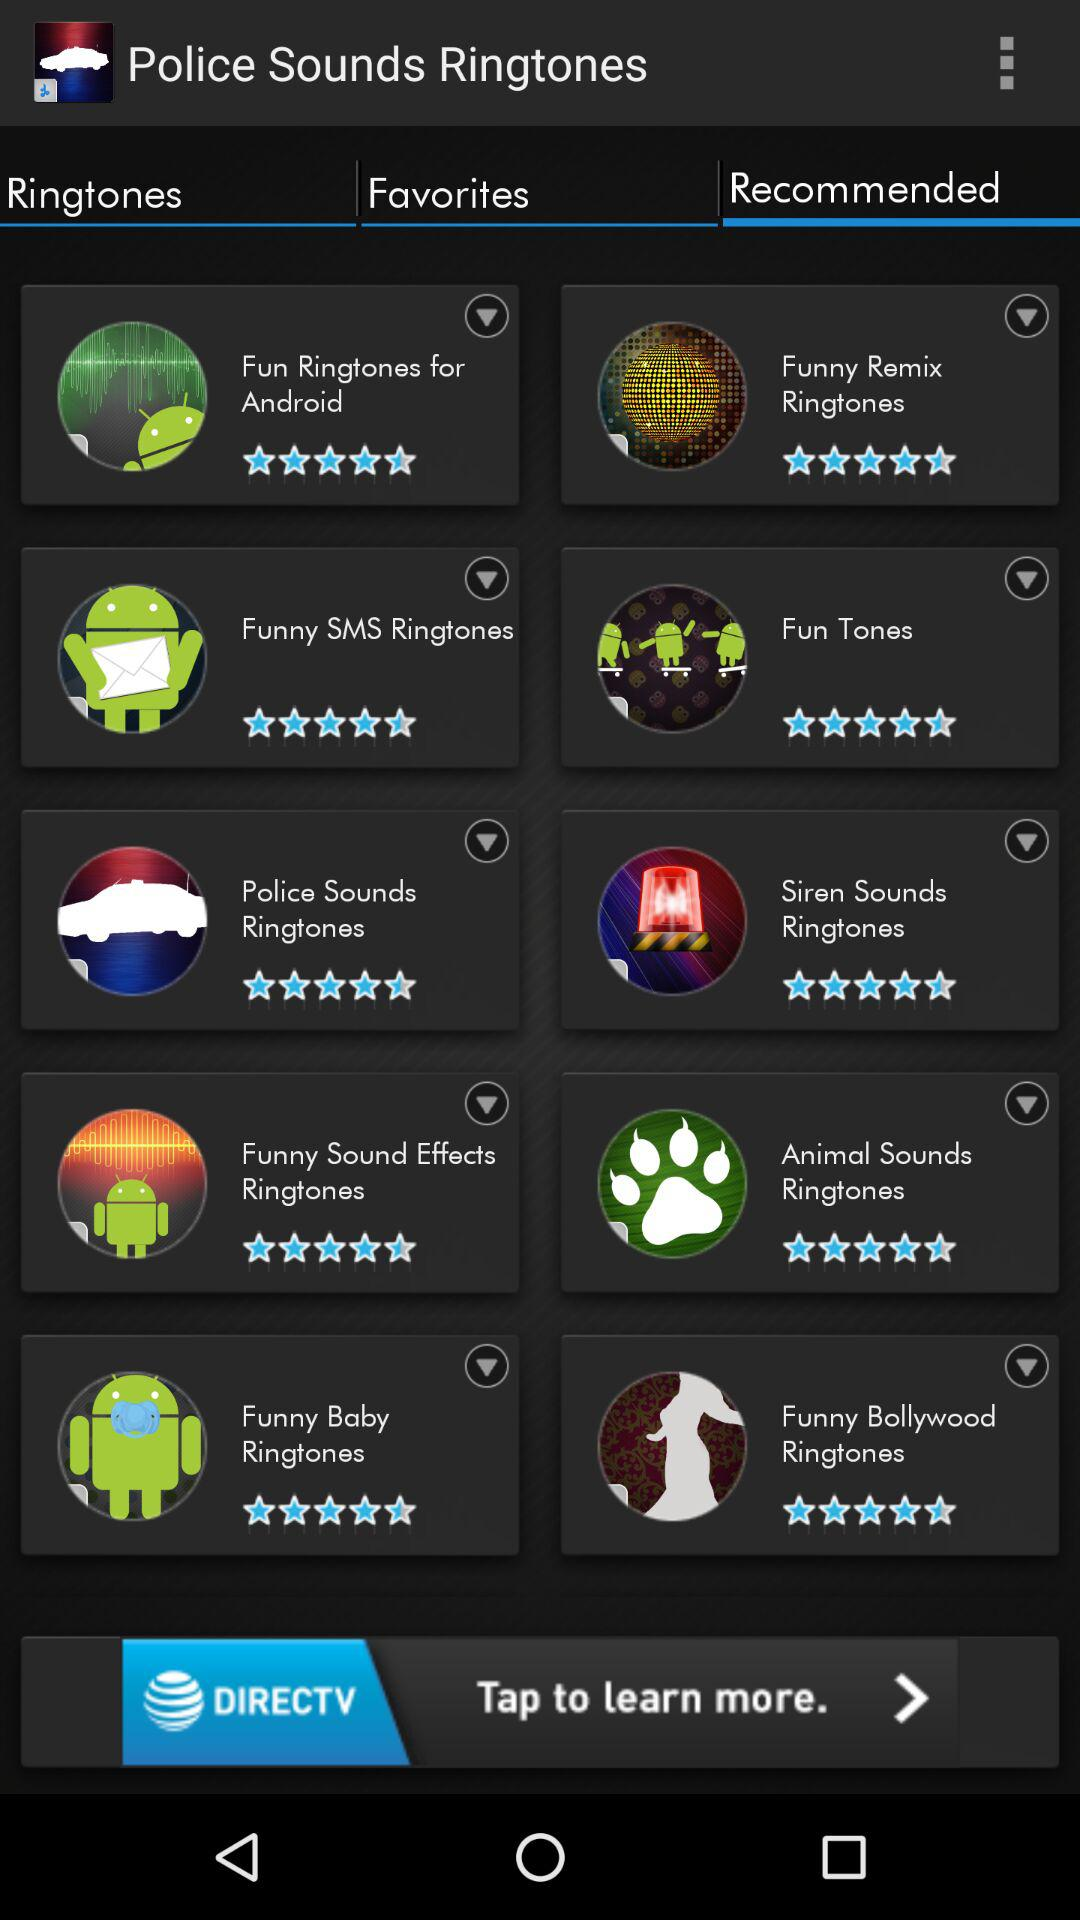Which option is selected in the "Police Sounds Ringtones"? The selected option is "Recommended". 